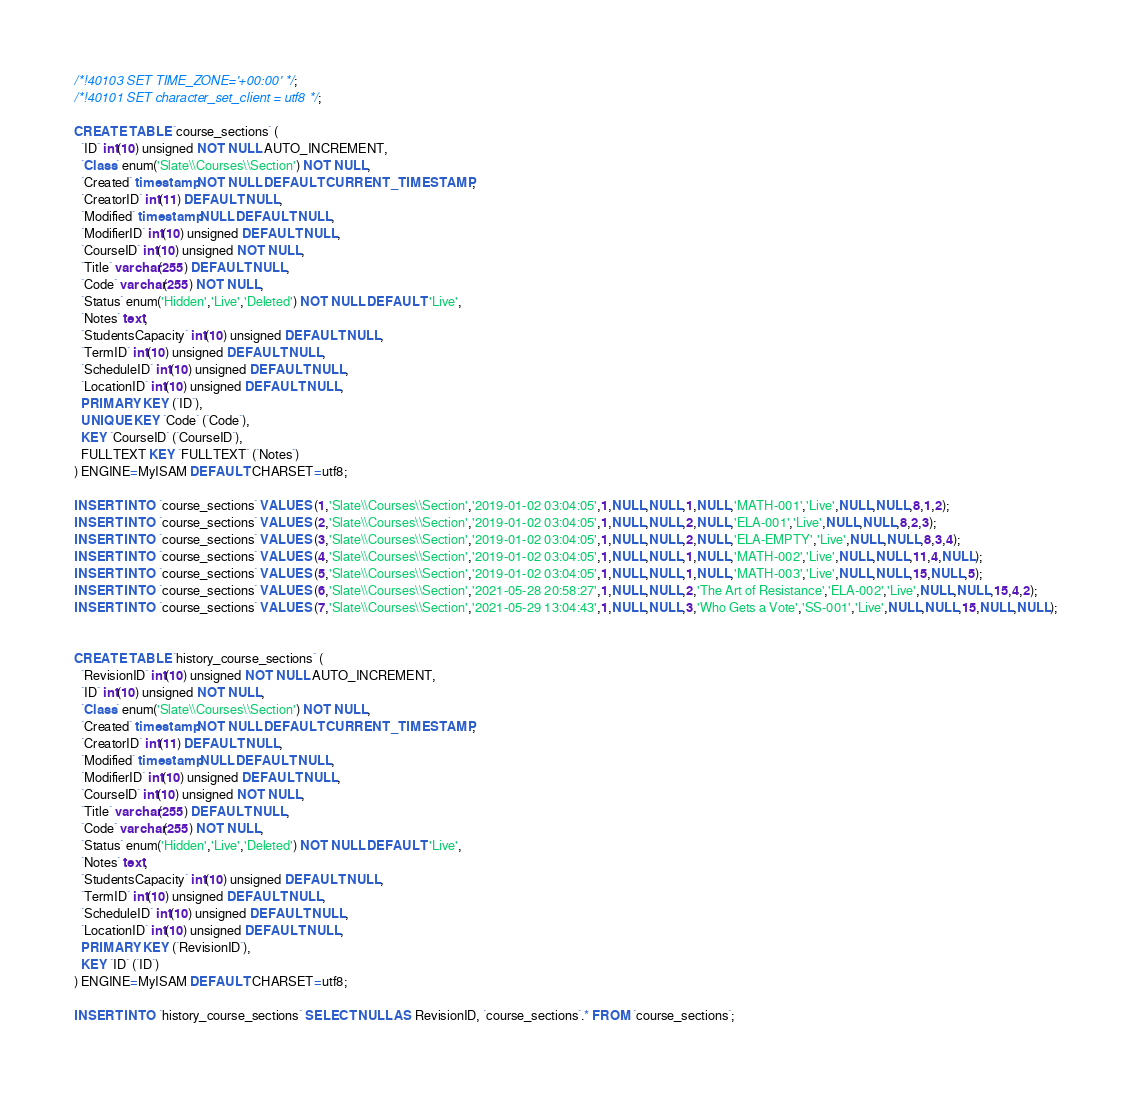<code> <loc_0><loc_0><loc_500><loc_500><_SQL_>/*!40103 SET TIME_ZONE='+00:00' */;
/*!40101 SET character_set_client = utf8 */;

CREATE TABLE `course_sections` (
  `ID` int(10) unsigned NOT NULL AUTO_INCREMENT,
  `Class` enum('Slate\\Courses\\Section') NOT NULL,
  `Created` timestamp NOT NULL DEFAULT CURRENT_TIMESTAMP,
  `CreatorID` int(11) DEFAULT NULL,
  `Modified` timestamp NULL DEFAULT NULL,
  `ModifierID` int(10) unsigned DEFAULT NULL,
  `CourseID` int(10) unsigned NOT NULL,
  `Title` varchar(255) DEFAULT NULL,
  `Code` varchar(255) NOT NULL,
  `Status` enum('Hidden','Live','Deleted') NOT NULL DEFAULT 'Live',
  `Notes` text,
  `StudentsCapacity` int(10) unsigned DEFAULT NULL,
  `TermID` int(10) unsigned DEFAULT NULL,
  `ScheduleID` int(10) unsigned DEFAULT NULL,
  `LocationID` int(10) unsigned DEFAULT NULL,
  PRIMARY KEY (`ID`),
  UNIQUE KEY `Code` (`Code`),
  KEY `CourseID` (`CourseID`),
  FULLTEXT KEY `FULLTEXT` (`Notes`)
) ENGINE=MyISAM DEFAULT CHARSET=utf8;

INSERT INTO `course_sections` VALUES (1,'Slate\\Courses\\Section','2019-01-02 03:04:05',1,NULL,NULL,1,NULL,'MATH-001','Live',NULL,NULL,8,1,2);
INSERT INTO `course_sections` VALUES (2,'Slate\\Courses\\Section','2019-01-02 03:04:05',1,NULL,NULL,2,NULL,'ELA-001','Live',NULL,NULL,8,2,3);
INSERT INTO `course_sections` VALUES (3,'Slate\\Courses\\Section','2019-01-02 03:04:05',1,NULL,NULL,2,NULL,'ELA-EMPTY','Live',NULL,NULL,8,3,4);
INSERT INTO `course_sections` VALUES (4,'Slate\\Courses\\Section','2019-01-02 03:04:05',1,NULL,NULL,1,NULL,'MATH-002','Live',NULL,NULL,11,4,NULL);
INSERT INTO `course_sections` VALUES (5,'Slate\\Courses\\Section','2019-01-02 03:04:05',1,NULL,NULL,1,NULL,'MATH-003','Live',NULL,NULL,15,NULL,5);
INSERT INTO `course_sections` VALUES (6,'Slate\\Courses\\Section','2021-05-28 20:58:27',1,NULL,NULL,2,'The Art of Resistance','ELA-002','Live',NULL,NULL,15,4,2);
INSERT INTO `course_sections` VALUES (7,'Slate\\Courses\\Section','2021-05-29 13:04:43',1,NULL,NULL,3,'Who Gets a Vote','SS-001','Live',NULL,NULL,15,NULL,NULL);


CREATE TABLE `history_course_sections` (
  `RevisionID` int(10) unsigned NOT NULL AUTO_INCREMENT,
  `ID` int(10) unsigned NOT NULL,
  `Class` enum('Slate\\Courses\\Section') NOT NULL,
  `Created` timestamp NOT NULL DEFAULT CURRENT_TIMESTAMP,
  `CreatorID` int(11) DEFAULT NULL,
  `Modified` timestamp NULL DEFAULT NULL,
  `ModifierID` int(10) unsigned DEFAULT NULL,
  `CourseID` int(10) unsigned NOT NULL,
  `Title` varchar(255) DEFAULT NULL,
  `Code` varchar(255) NOT NULL,
  `Status` enum('Hidden','Live','Deleted') NOT NULL DEFAULT 'Live',
  `Notes` text,
  `StudentsCapacity` int(10) unsigned DEFAULT NULL,
  `TermID` int(10) unsigned DEFAULT NULL,
  `ScheduleID` int(10) unsigned DEFAULT NULL,
  `LocationID` int(10) unsigned DEFAULT NULL,
  PRIMARY KEY (`RevisionID`),
  KEY `ID` (`ID`)
) ENGINE=MyISAM DEFAULT CHARSET=utf8;

INSERT INTO `history_course_sections` SELECT NULL AS RevisionID, `course_sections`.* FROM `course_sections`;
</code> 